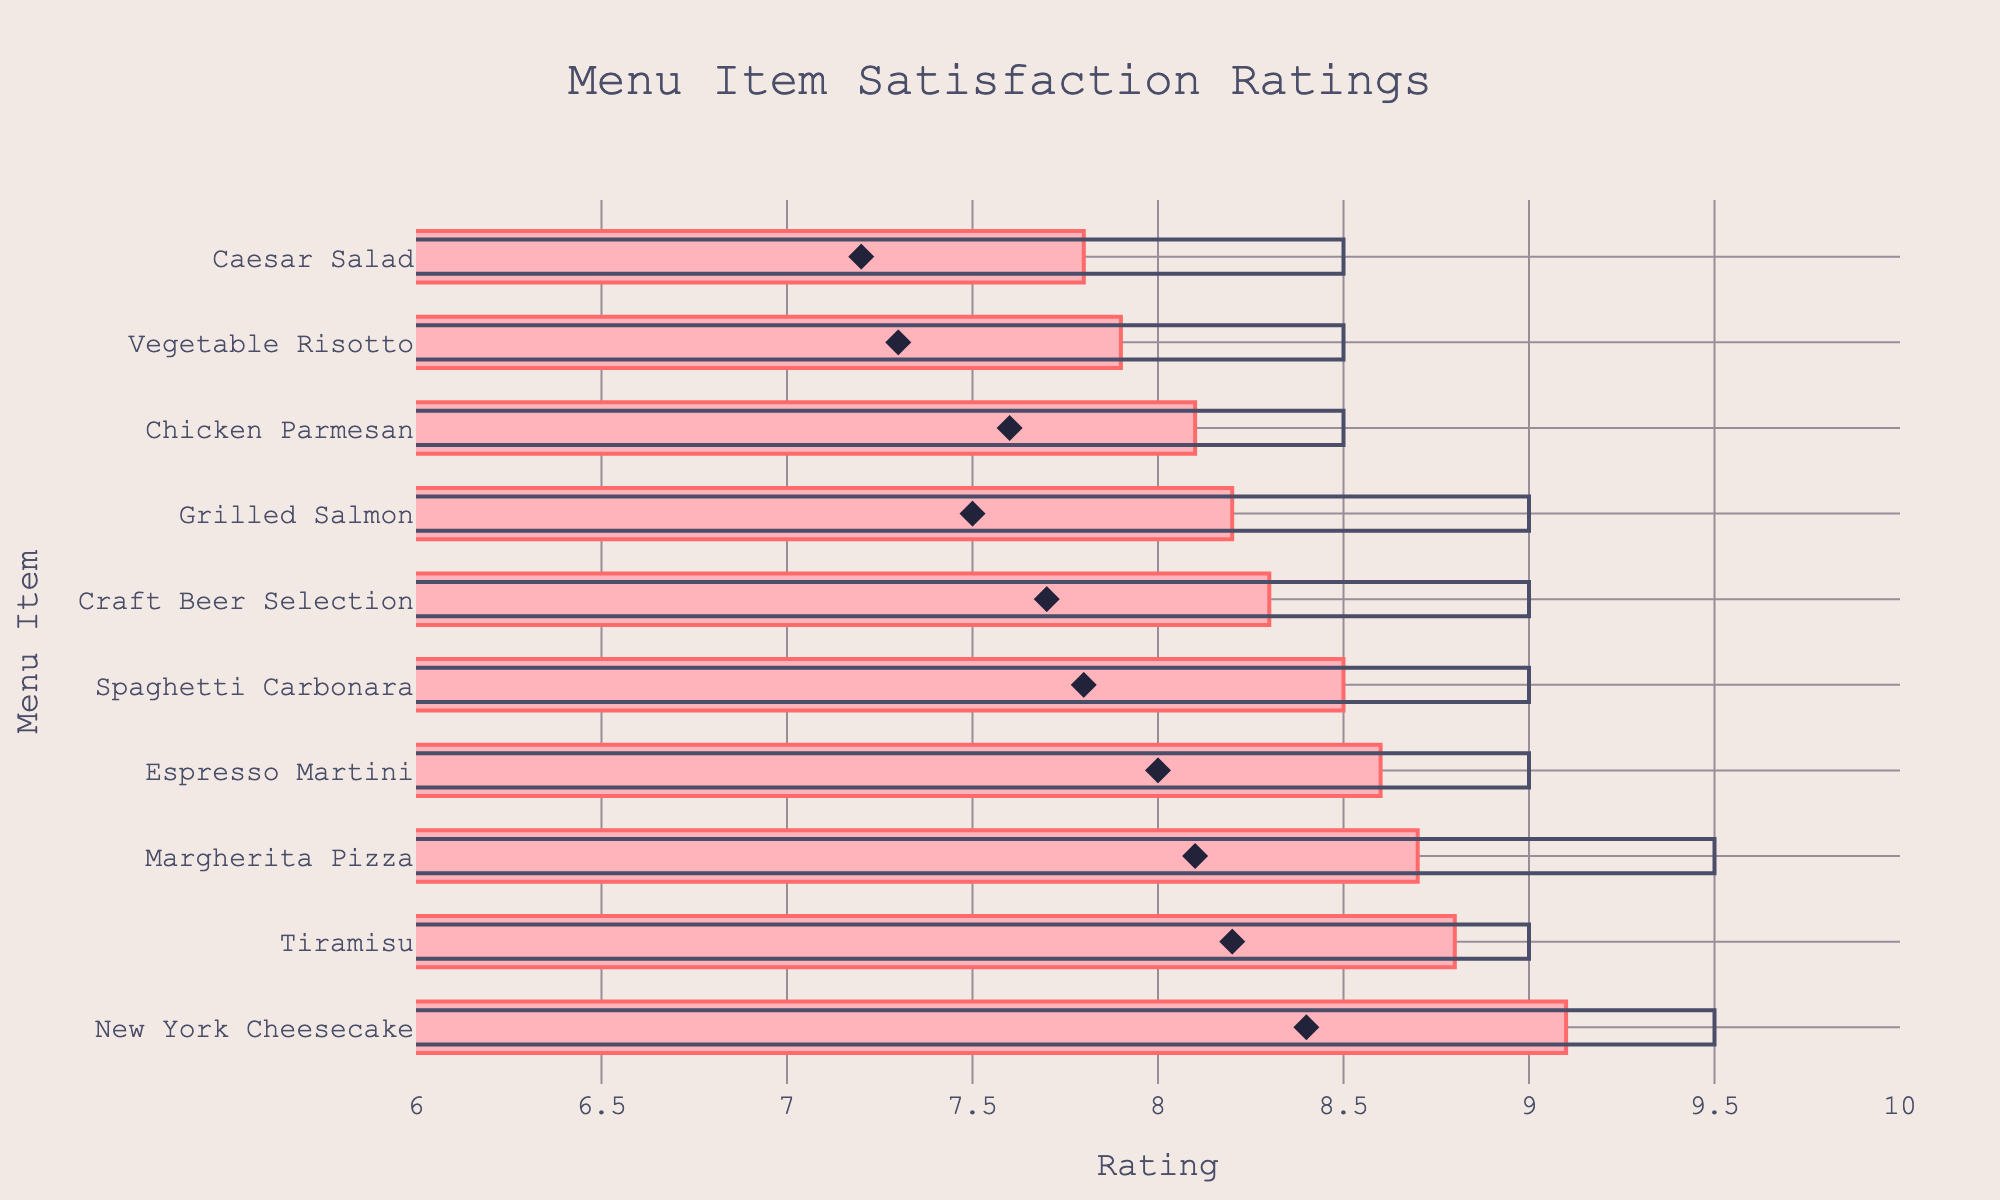How many menu items have their average rating indicated by a diamond marker? There are diamond markers placed next to each menu item to indicate their average ratings.
Answer: 10 What is the satisfaction rating of New York Cheesecake? According to the plot, the bar for New York Cheesecake extends to the 9.1 mark on the x-axis.
Answer: 9.1 Which menu item has the highest satisfaction rating? By observing the bars, New York Cheesecake has the longest bar extending to 9.1, which is the highest rating.
Answer: New York Cheesecake How does the satisfaction rating of Caesar Salad compare to its target rating? The target rating bar for Caesar Salad extends to 8.5, while the satisfaction rating bar extends to 7.8. Hence, the satisfaction rating is lower than the target.
Answer: Lower By how much does the satisfaction rating of Chicken Parmesan exceed its average rating? The satisfaction rating for Chicken Parmesan is 8.1, and the average rating is marked at 7.6. The difference is 8.1 - 7.6.
Answer: 0.5 Which menu item is closest to hitting its target rating? Tiramisu, with a satisfaction rating of 8.8, is very close to its target rating of 9, with a difference of only 0.2.
Answer: Tiramisu What's the color used to represent the target ratings? The bars for target ratings are depicted with a transparent fill but have a border colored in dark shades (black/dark grey).
Answer: Black/Dark Grey Are there any menu items that exceed their target ratings? Observing the bars, none of the satisfaction ratings for the menu items exceed their respective target ratings.
Answer: No What is the average rating for Margherita Pizza? According to the plot, a diamond marker represents an average rating of 8.1 for Margherita Pizza.
Answer: 8.1 Which menu item has the lowest satisfaction rating, and what is that rating? The plot shows Grilled Salmon has the shortest bar, extending to 8.2, which is the lowest satisfaction rating.
Answer: Grilled Salmon, 8.2 